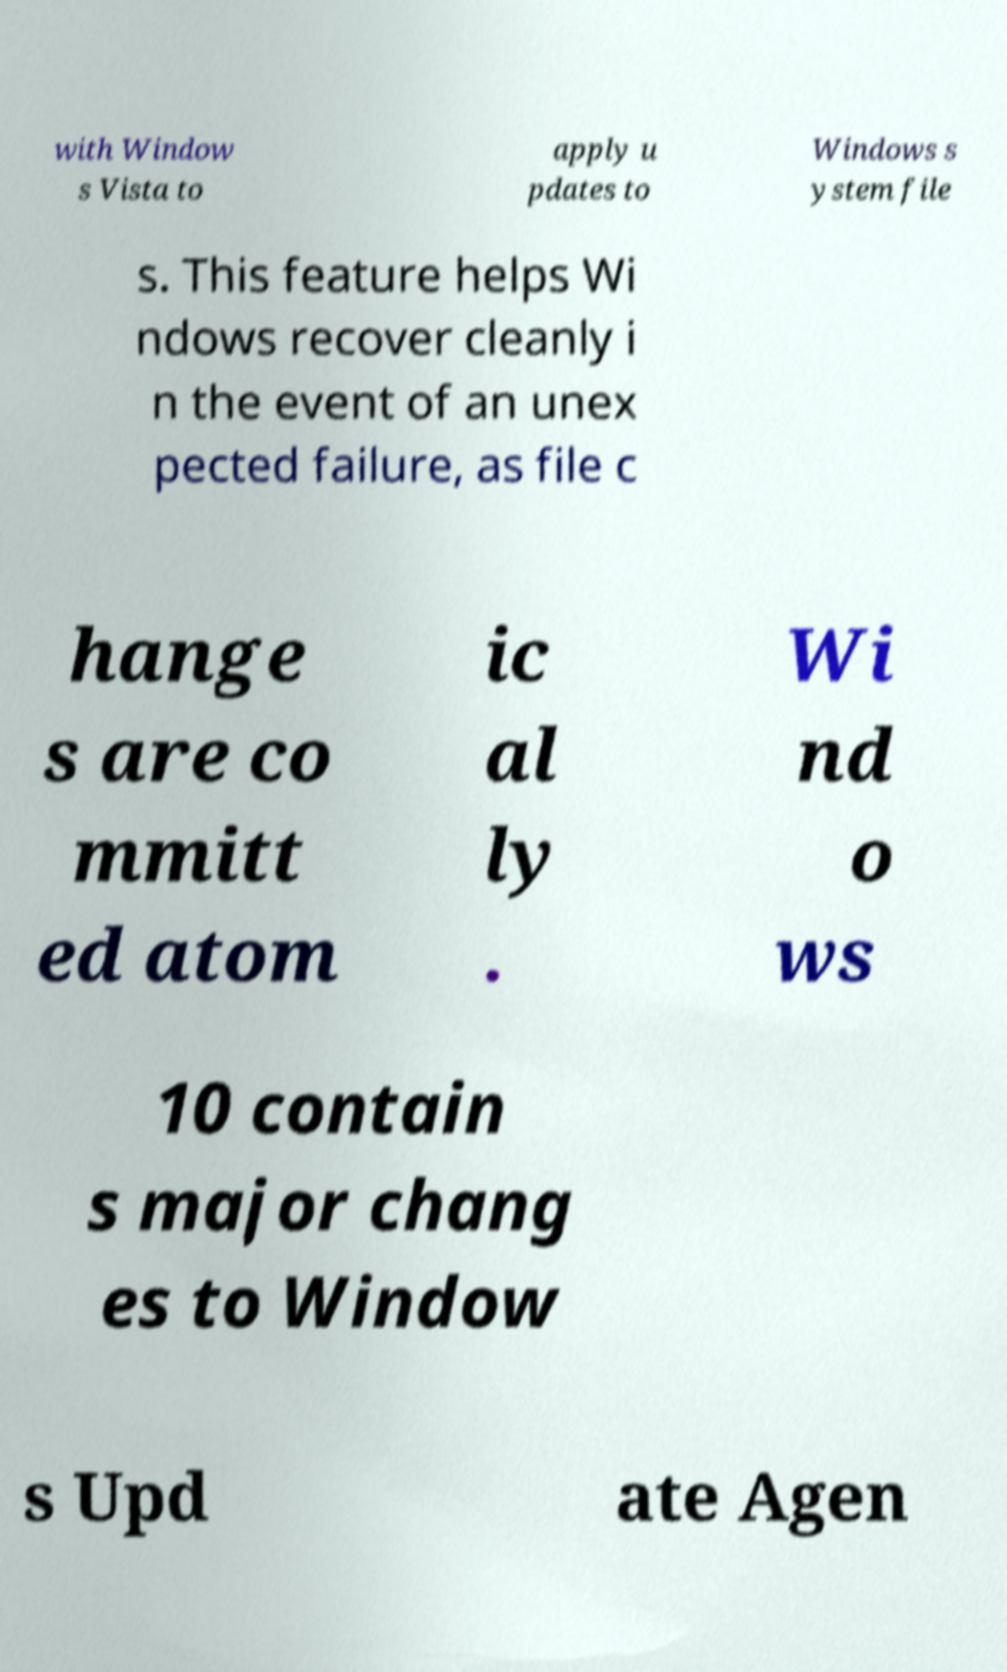For documentation purposes, I need the text within this image transcribed. Could you provide that? with Window s Vista to apply u pdates to Windows s ystem file s. This feature helps Wi ndows recover cleanly i n the event of an unex pected failure, as file c hange s are co mmitt ed atom ic al ly . Wi nd o ws 10 contain s major chang es to Window s Upd ate Agen 